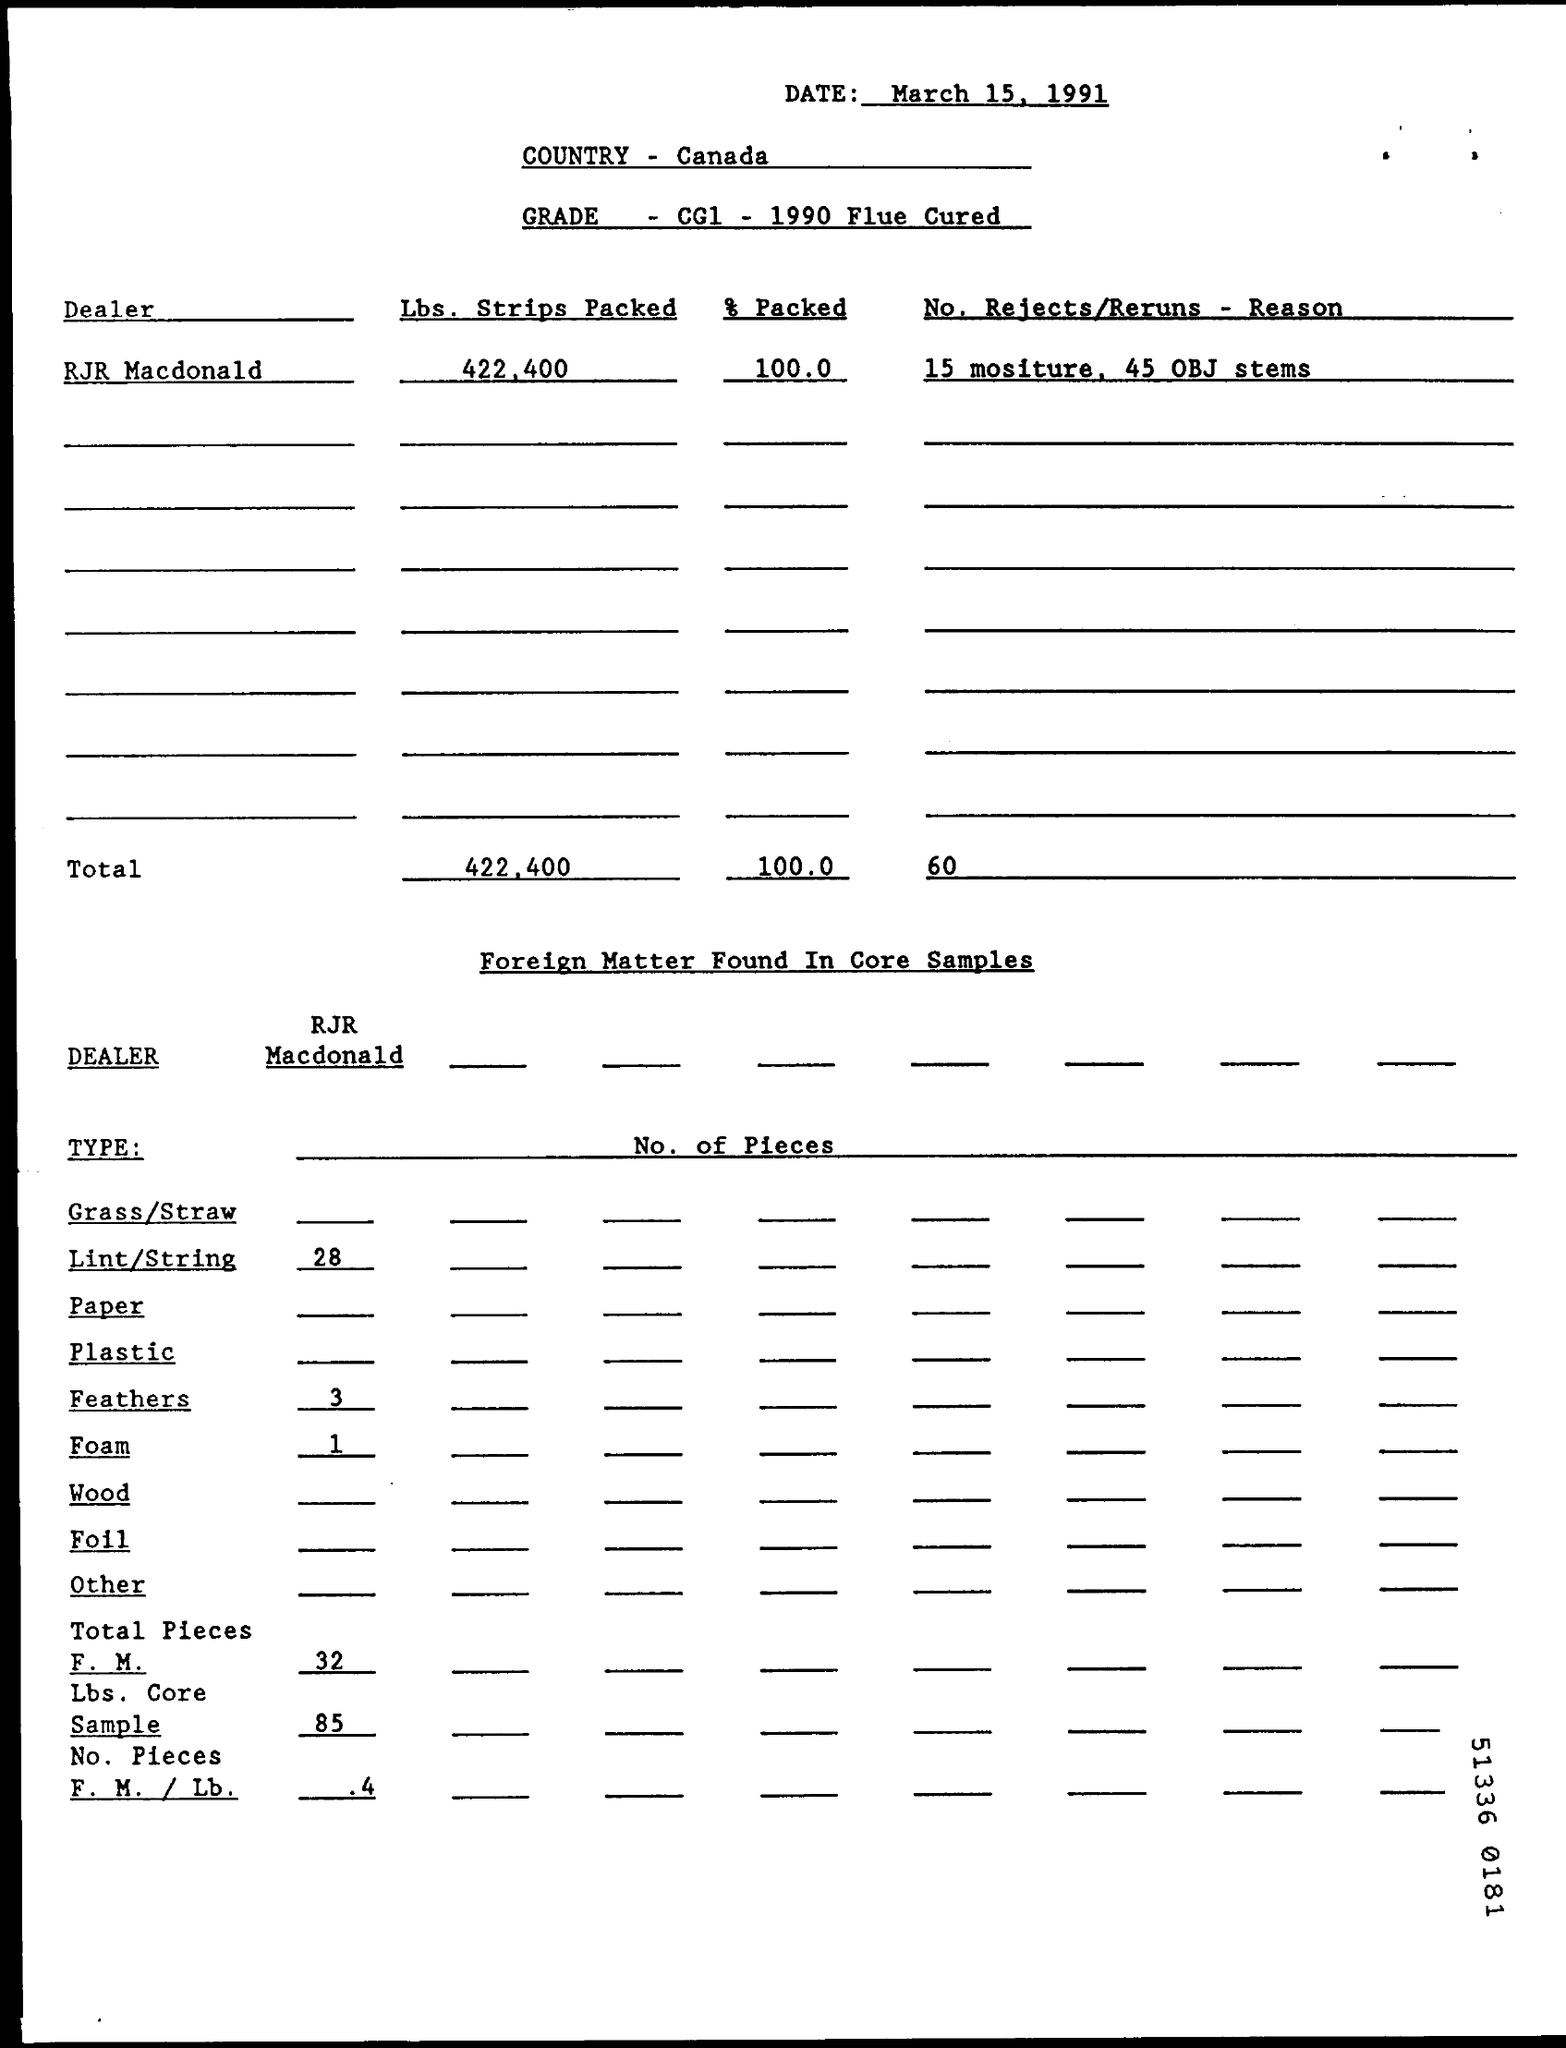When is the document dated?
Your answer should be compact. March 15, 1991. Which country is mentioned?
Make the answer very short. Canada. What is the grade specified?
Your answer should be compact. CG1 - 1990 Flue Cured. 